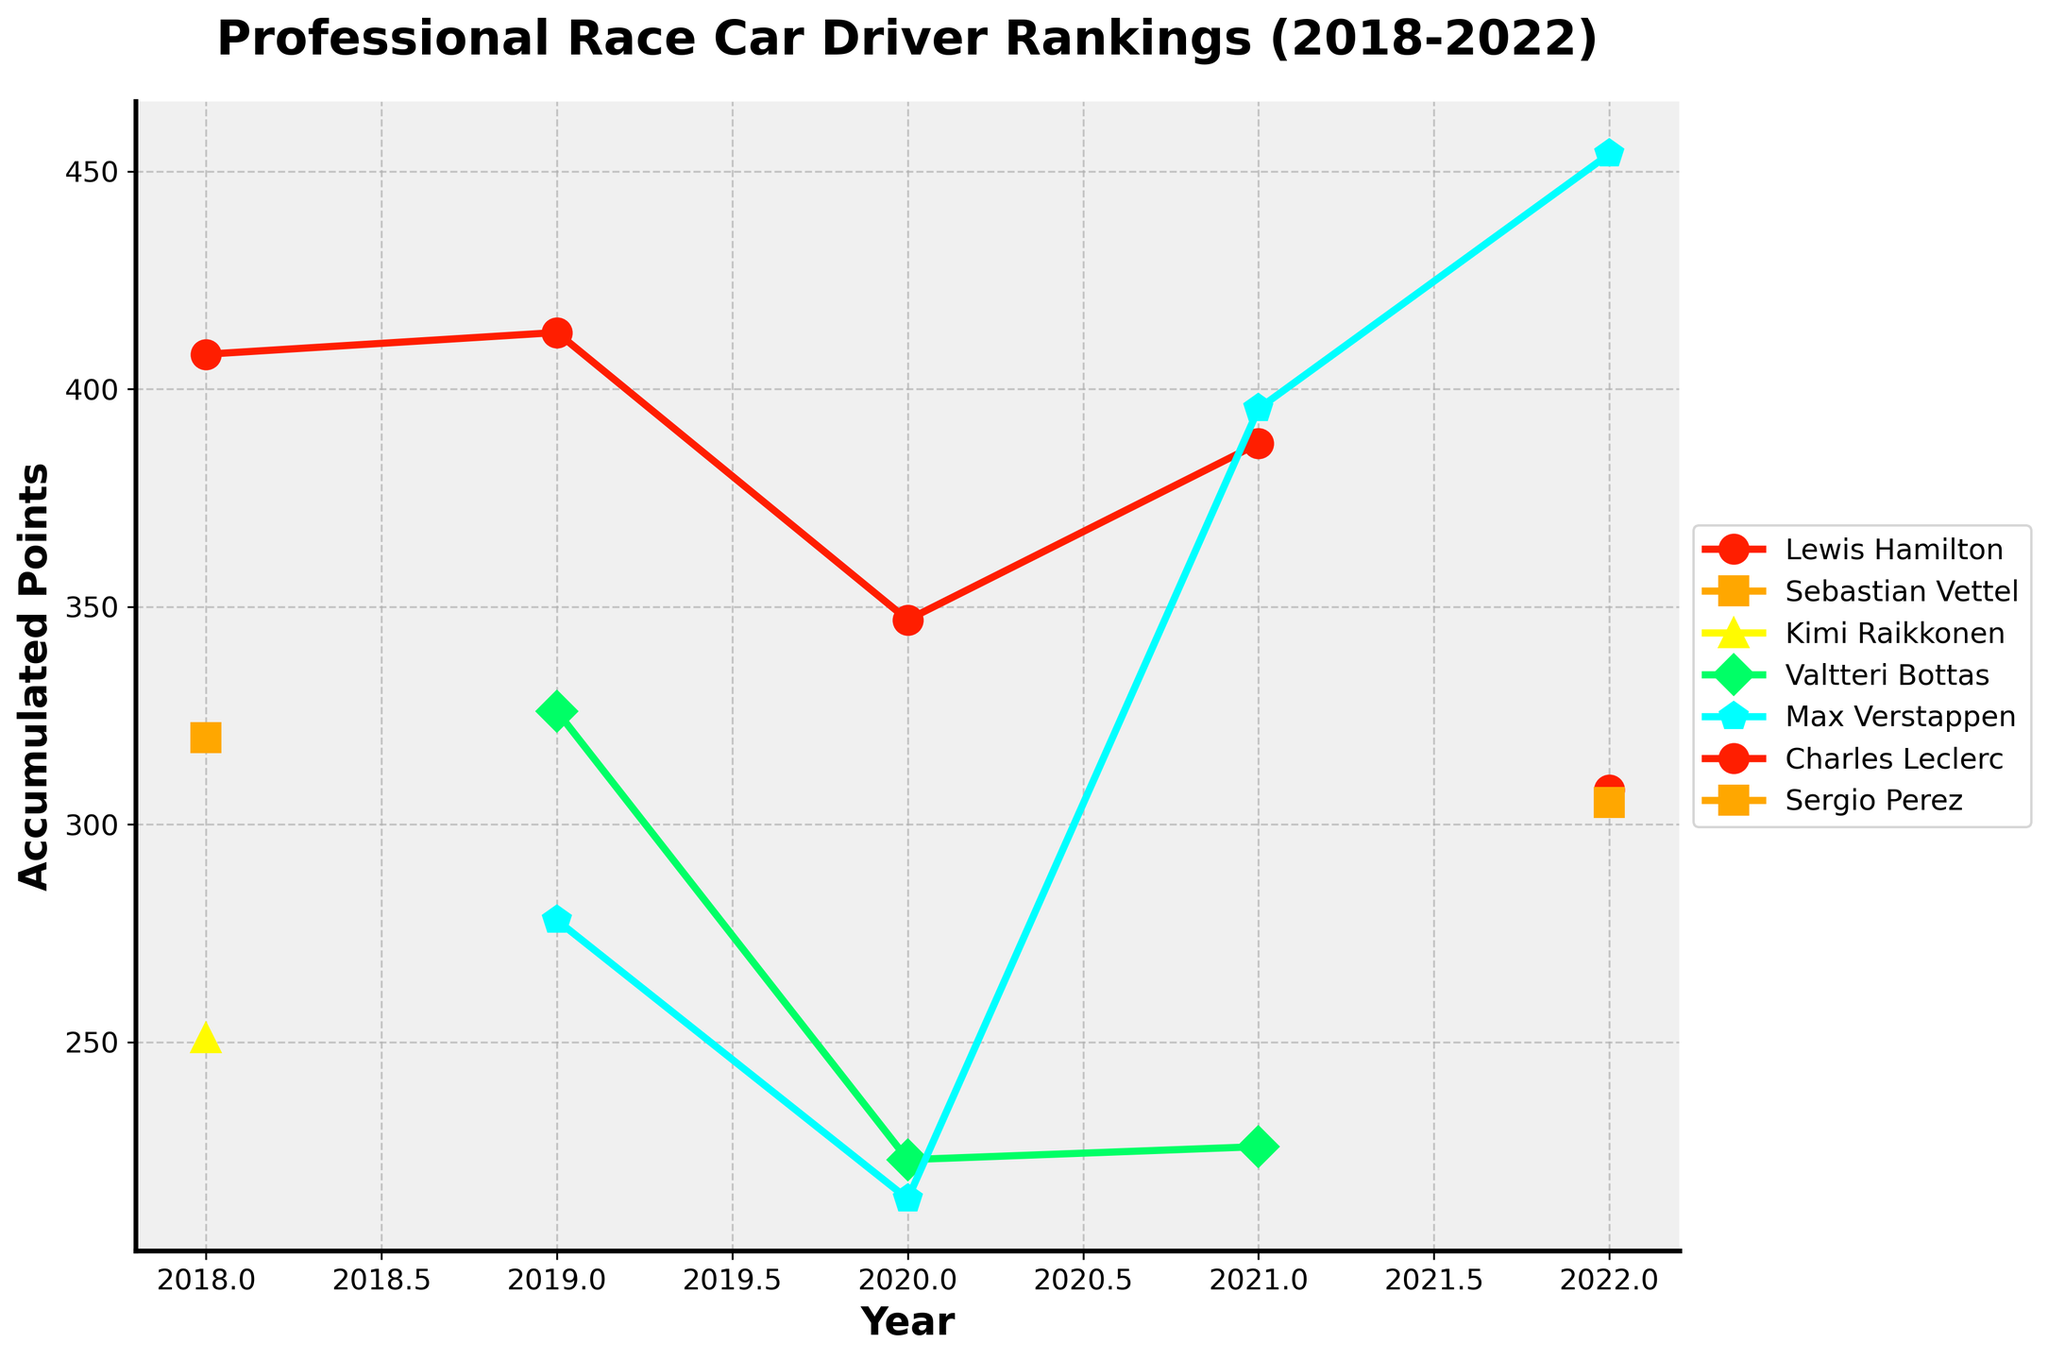what is the title of the plot? The title is typically found at the top of the plot, providing an overall description of the data being presented.
Answer: Professional Race Car Driver Rankings (2018-2022) Which driver has the highest accumulated points in 2022? Identify the point with the highest value on the y-axis for the year 2022 and check the corresponding driver's name.
Answer: Max Verstappen How many drivers are represented in the plot? Count the number of unique drivers listed in the legend of the plot.
Answer: 7 Which year did Lewis Hamilton have the highest accumulated points? Look for the maximum point corresponding to Lewis Hamilton across all years on the y-axis.
Answer: 2019 Who had a higher accumulated point in 2021, Max Verstappen or Lewis Hamilton? Compare the y-axis values corresponding to Max Verstappen and Lewis Hamilton for the year 2021.
Answer: Max Verstappen What is the total accumulated points for Max Verstappen from 2019 to 2022? Sum the accumulated points for Max Verstappen for each year from 2019 to 2022.
Answer: 1341.5 Which driver shows the most consistent improvement in their ranking over the years? Identify the driver whose line mostly trends upwards consistently across the years.
Answer: Max Verstappen In which year did Sebastian Vettel rank second, and what were his accumulated points? Find the year in the x-axis where Sebastian Vettel is plotted second as per legend, and note his accumulated points on the y-axis for that year.
Answer: 2018, 320 Who scored more points in 2020, Valtteri Bottas or Max Verstappen? Compare the accumulated points on the y-axis for Valtteri Bottas and Max Verstappen for the year 2020.
Answer: Valtteri Bottas What is the average accumulated points for the top-ranked drivers each year between 2018 to 2022? Calculate the average of the accumulated points for drivers ranked 1st each year from 2018 to 2022 and divide by the total number of years.
Answer: (408 + 413 + 347 + 395.5 + 454) / 5 = 403.1 